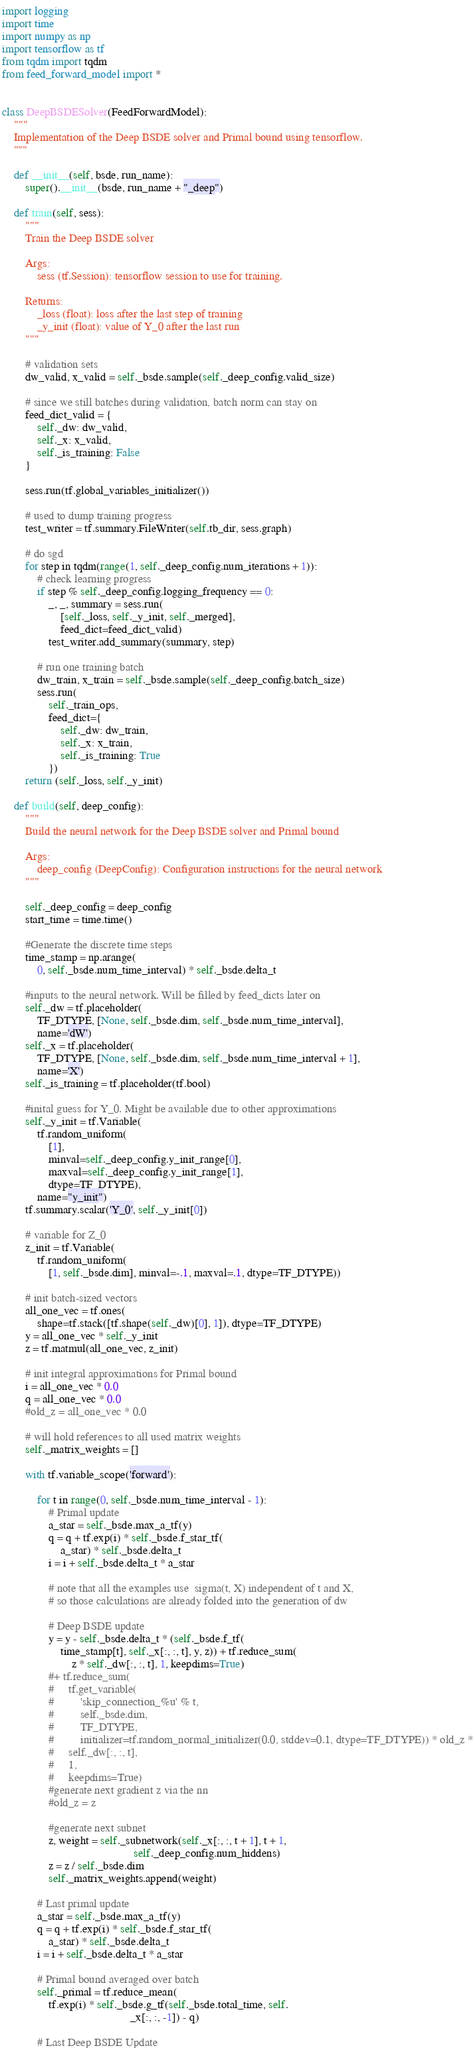<code> <loc_0><loc_0><loc_500><loc_500><_Python_>import logging
import time
import numpy as np
import tensorflow as tf
from tqdm import tqdm
from feed_forward_model import *


class DeepBSDESolver(FeedForwardModel):
    """
    Implementation of the Deep BSDE solver and Primal bound using tensorflow.
    """

    def __init__(self, bsde, run_name):
        super().__init__(bsde, run_name + "_deep")

    def train(self, sess):
        """
        Train the Deep BSDE solver

        Args:
            sess (tf.Session): tensorflow session to use for training.

        Returns:
            _loss (float): loss after the last step of training
            _y_init (float): value of Y_0 after the last run
        """

        # validation sets
        dw_valid, x_valid = self._bsde.sample(self._deep_config.valid_size)

        # since we still batches during validation, batch norm can stay on
        feed_dict_valid = {
            self._dw: dw_valid,
            self._x: x_valid,
            self._is_training: False
        }

        sess.run(tf.global_variables_initializer())

        # used to dump training progress
        test_writer = tf.summary.FileWriter(self.tb_dir, sess.graph)

        # do sgd
        for step in tqdm(range(1, self._deep_config.num_iterations + 1)):
            # check learning progress
            if step % self._deep_config.logging_frequency == 0:
                _, _, summary = sess.run(
                    [self._loss, self._y_init, self._merged],
                    feed_dict=feed_dict_valid)
                test_writer.add_summary(summary, step)

            # run one training batch
            dw_train, x_train = self._bsde.sample(self._deep_config.batch_size)
            sess.run(
                self._train_ops,
                feed_dict={
                    self._dw: dw_train,
                    self._x: x_train,
                    self._is_training: True
                })
        return (self._loss, self._y_init)

    def build(self, deep_config):
        """
        Build the neural network for the Deep BSDE solver and Primal bound

        Args:
            deep_config (DeepConfig): Configuration instructions for the neural network
        """

        self._deep_config = deep_config
        start_time = time.time()

        #Generate the discrete time steps
        time_stamp = np.arange(
            0, self._bsde.num_time_interval) * self._bsde.delta_t

        #inputs to the neural network. Will be filled by feed_dicts later on
        self._dw = tf.placeholder(
            TF_DTYPE, [None, self._bsde.dim, self._bsde.num_time_interval],
            name='dW')
        self._x = tf.placeholder(
            TF_DTYPE, [None, self._bsde.dim, self._bsde.num_time_interval + 1],
            name='X')
        self._is_training = tf.placeholder(tf.bool)

        #inital guess for Y_0. Might be available due to other approximations
        self._y_init = tf.Variable(
            tf.random_uniform(
                [1],
                minval=self._deep_config.y_init_range[0],
                maxval=self._deep_config.y_init_range[1],
                dtype=TF_DTYPE),
            name="y_init")
        tf.summary.scalar('Y_0', self._y_init[0])

        # variable for Z_0
        z_init = tf.Variable(
            tf.random_uniform(
                [1, self._bsde.dim], minval=-.1, maxval=.1, dtype=TF_DTYPE))

        # init batch-sized vectors
        all_one_vec = tf.ones(
            shape=tf.stack([tf.shape(self._dw)[0], 1]), dtype=TF_DTYPE)
        y = all_one_vec * self._y_init
        z = tf.matmul(all_one_vec, z_init)

        # init integral approximations for Primal bound
        i = all_one_vec * 0.0
        q = all_one_vec * 0.0
        #old_z = all_one_vec * 0.0

        # will hold references to all used matrix weights
        self._matrix_weights = []

        with tf.variable_scope('forward'):

            for t in range(0, self._bsde.num_time_interval - 1):
                # Primal update
                a_star = self._bsde.max_a_tf(y)
                q = q + tf.exp(i) * self._bsde.f_star_tf(
                    a_star) * self._bsde.delta_t
                i = i + self._bsde.delta_t * a_star

                # note that all the examples use  sigma(t, X) independent of t and X,
                # so those calculations are already folded into the generation of dw

                # Deep BSDE update
                y = y - self._bsde.delta_t * (self._bsde.f_tf(
                    time_stamp[t], self._x[:, :, t], y, z)) + tf.reduce_sum(
                        z * self._dw[:, :, t], 1, keepdims=True)
                #+ tf.reduce_sum(
                #     tf.get_variable(
                #         'skip_connection_%u' % t,
                #         self._bsde.dim,
                #         TF_DTYPE,
                #         initializer=tf.random_normal_initializer(0.0, stddev=0.1, dtype=TF_DTYPE)) * old_z *
                #     self._dw[:, :, t],
                #     1,
                #     keepdims=True)
                #generate next gradient z via the nn
                #old_z = z

                #generate next subnet
                z, weight = self._subnetwork(self._x[:, :, t + 1], t + 1,
                                             self._deep_config.num_hiddens)
                z = z / self._bsde.dim
                self._matrix_weights.append(weight)

            # Last primal update
            a_star = self._bsde.max_a_tf(y)
            q = q + tf.exp(i) * self._bsde.f_star_tf(
                a_star) * self._bsde.delta_t
            i = i + self._bsde.delta_t * a_star

            # Primal bound averaged over batch
            self._primal = tf.reduce_mean(
                tf.exp(i) * self._bsde.g_tf(self._bsde.total_time, self.
                                            _x[:, :, -1]) - q)

            # Last Deep BSDE Update</code> 